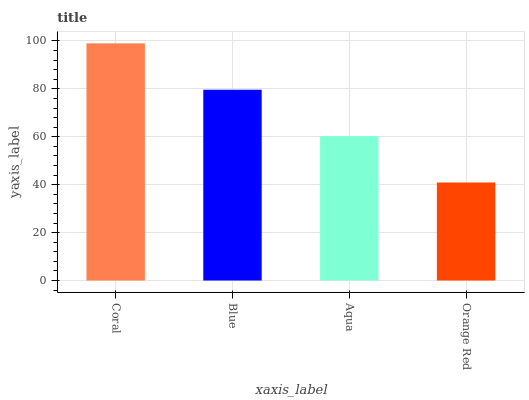Is Orange Red the minimum?
Answer yes or no. Yes. Is Coral the maximum?
Answer yes or no. Yes. Is Blue the minimum?
Answer yes or no. No. Is Blue the maximum?
Answer yes or no. No. Is Coral greater than Blue?
Answer yes or no. Yes. Is Blue less than Coral?
Answer yes or no. Yes. Is Blue greater than Coral?
Answer yes or no. No. Is Coral less than Blue?
Answer yes or no. No. Is Blue the high median?
Answer yes or no. Yes. Is Aqua the low median?
Answer yes or no. Yes. Is Aqua the high median?
Answer yes or no. No. Is Orange Red the low median?
Answer yes or no. No. 